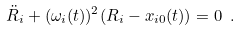Convert formula to latex. <formula><loc_0><loc_0><loc_500><loc_500>\ddot { R } _ { i } + ( \omega _ { i } ( t ) ) ^ { 2 } ( R _ { i } - x _ { i 0 } ( t ) ) = 0 \ .</formula> 